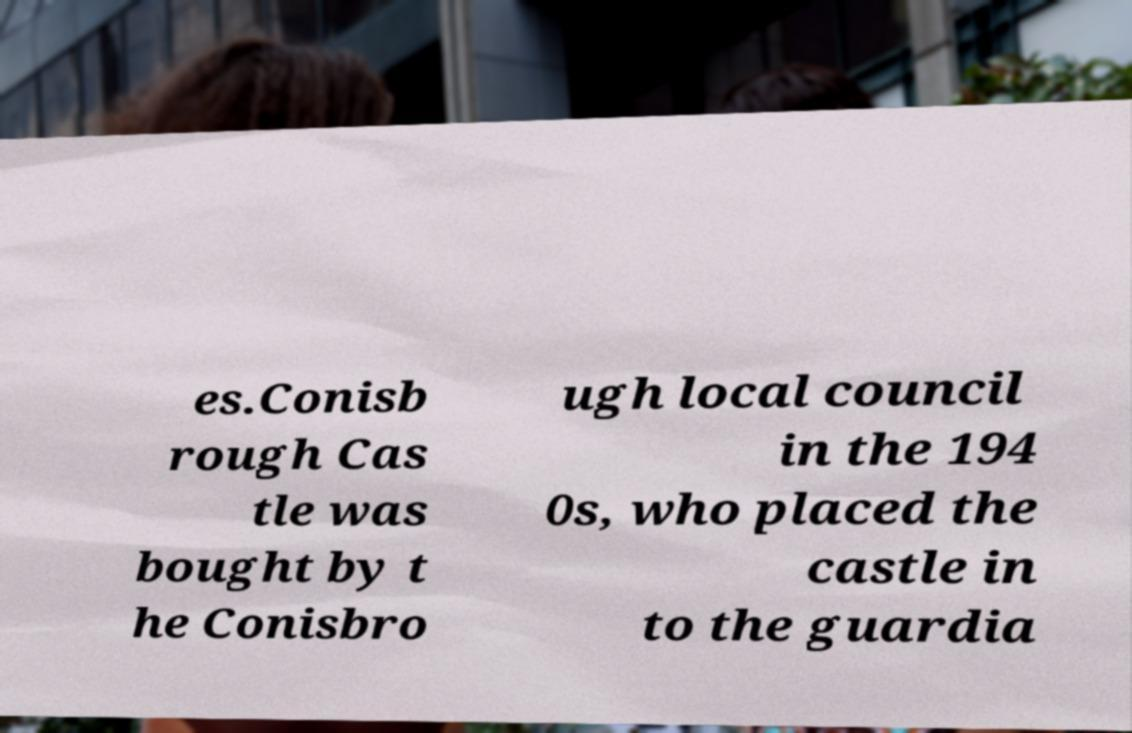What messages or text are displayed in this image? I need them in a readable, typed format. es.Conisb rough Cas tle was bought by t he Conisbro ugh local council in the 194 0s, who placed the castle in to the guardia 